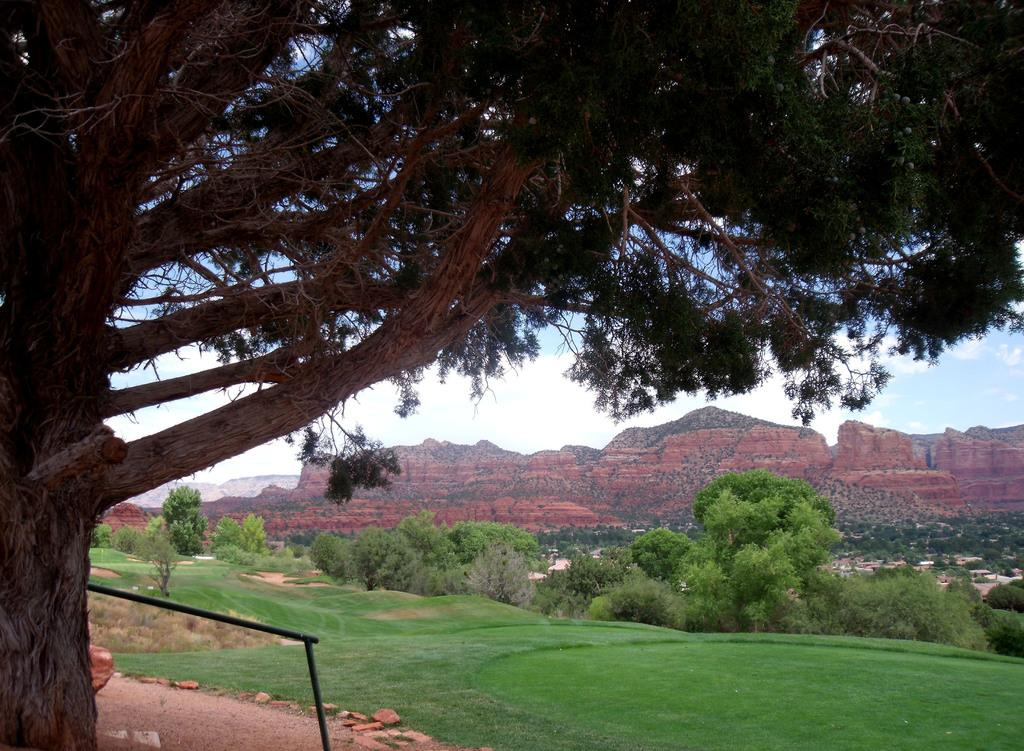What type of vegetation can be seen in the image? There is a group of trees in the image. What geographical features are present in the image? There is a group of hills in the image. What type of terrain is visible in the image? There is a grassy land visible in the image. Who made the decision to plant the trees in the image? There is no information provided about who made the decision to plant the trees in the image. What type of representative can be seen in the image? There are no representatives present in the image; it features a group of trees, hills, and grassy land. 